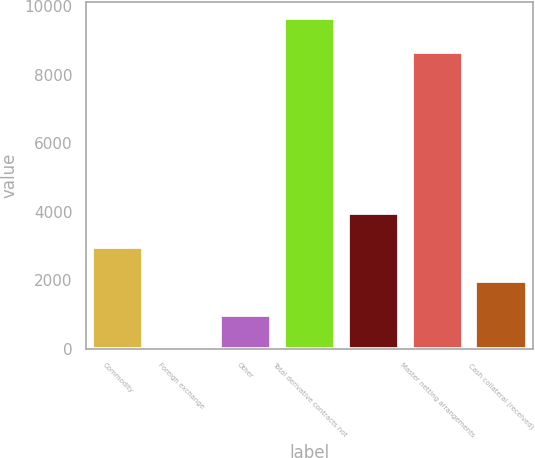Convert chart to OTSL. <chart><loc_0><loc_0><loc_500><loc_500><bar_chart><fcel>Commodity<fcel>Foreign exchange<fcel>Other<fcel>Total derivative contracts not<fcel>Unnamed: 4<fcel>Master netting arrangements<fcel>Cash collateral (received)<nl><fcel>2974.5<fcel>3<fcel>993.5<fcel>9643.5<fcel>3965<fcel>8653<fcel>1984<nl></chart> 